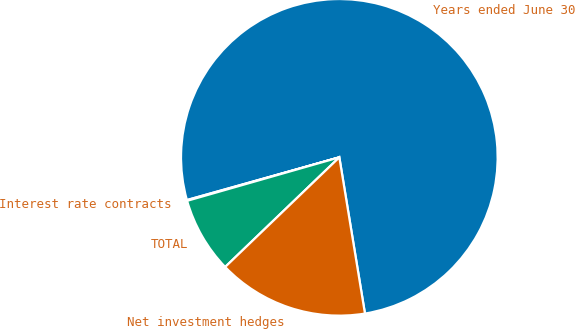<chart> <loc_0><loc_0><loc_500><loc_500><pie_chart><fcel>Years ended June 30<fcel>Interest rate contracts<fcel>TOTAL<fcel>Net investment hedges<nl><fcel>76.76%<fcel>0.08%<fcel>7.75%<fcel>15.41%<nl></chart> 